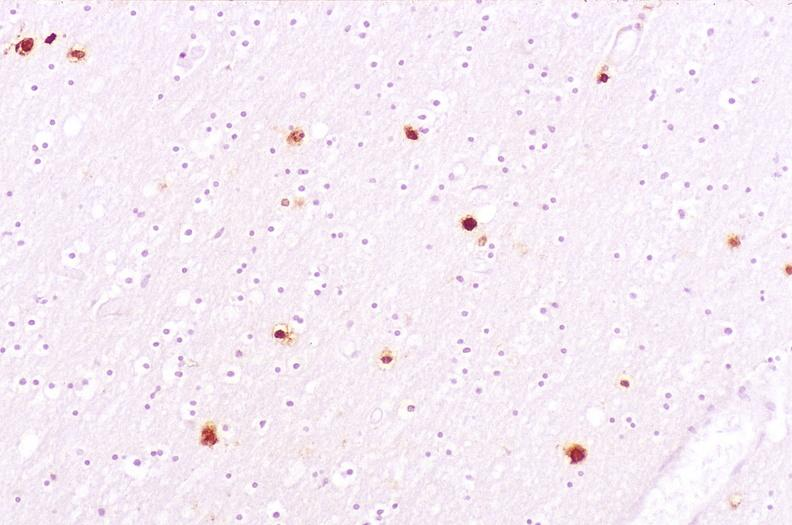do hyperplasia stain?
Answer the question using a single word or phrase. No 